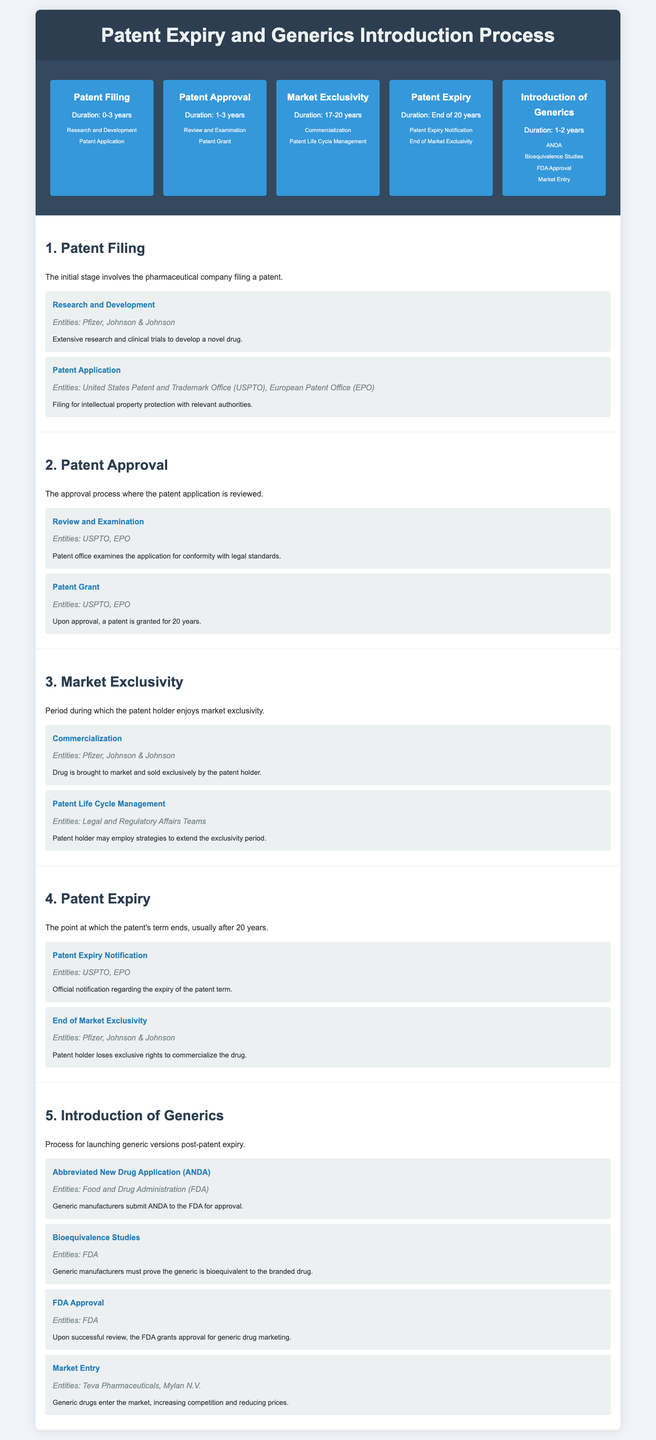What is the duration for Patent Filing? The duration listed for Patent Filing is 0-3 years.
Answer: 0-3 years Who are the entities involved in Patent Application? The entities mentioned for Patent Application are USPTO and EPO.
Answer: USPTO, EPO What events occur during Market Exclusivity? Key events listed during Market Exclusivity include Commercialization and Patent Life Cycle Management.
Answer: Commercialization, Patent Life Cycle Management What is the main entity responsible for ANDA? The primary entity responsible for ANDA is the FDA.
Answer: FDA How long is the Market Exclusivity period? The duration of the Market Exclusivity period is 17-20 years.
Answer: 17-20 years What happens at the end of Patent Expiry? At the end of Patent Expiry, the patent holder loses exclusive rights to commercialize the drug.
Answer: Loses exclusive rights What is required for generic approval after patent expiry? Bioequivalence studies are required for generic approval.
Answer: Bioequivalence studies Which companies enter the market for generics? Teva Pharmaceuticals and Mylan N.V. are the companies mentioned for generic market entry.
Answer: Teva Pharmaceuticals, Mylan N.V Which stage involves extensive research and clinical trials? The stage that involves extensive research and clinical trials is Patent Filing.
Answer: Patent Filing 